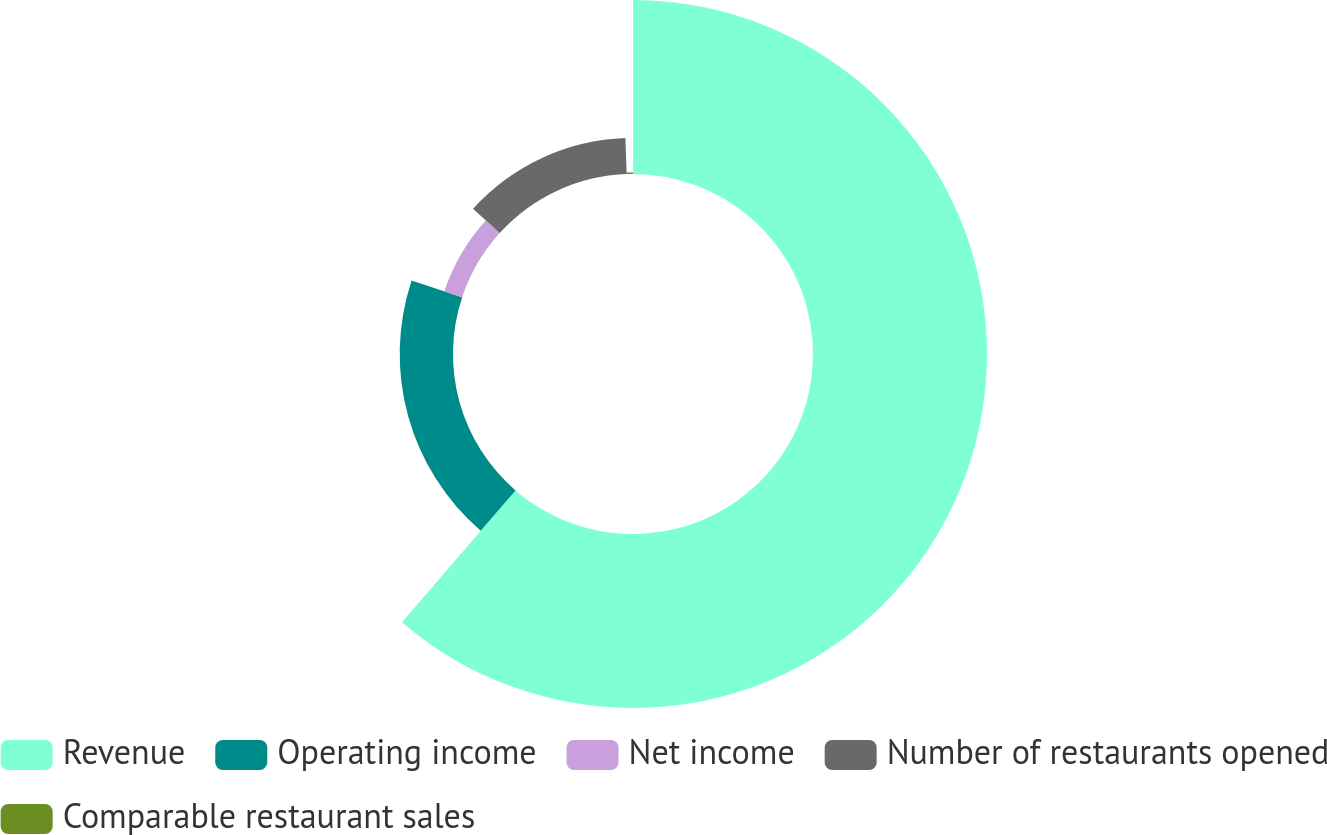Convert chart to OTSL. <chart><loc_0><loc_0><loc_500><loc_500><pie_chart><fcel>Revenue<fcel>Operating income<fcel>Net income<fcel>Number of restaurants opened<fcel>Comparable restaurant sales<nl><fcel>61.31%<fcel>18.78%<fcel>6.63%<fcel>12.71%<fcel>0.56%<nl></chart> 